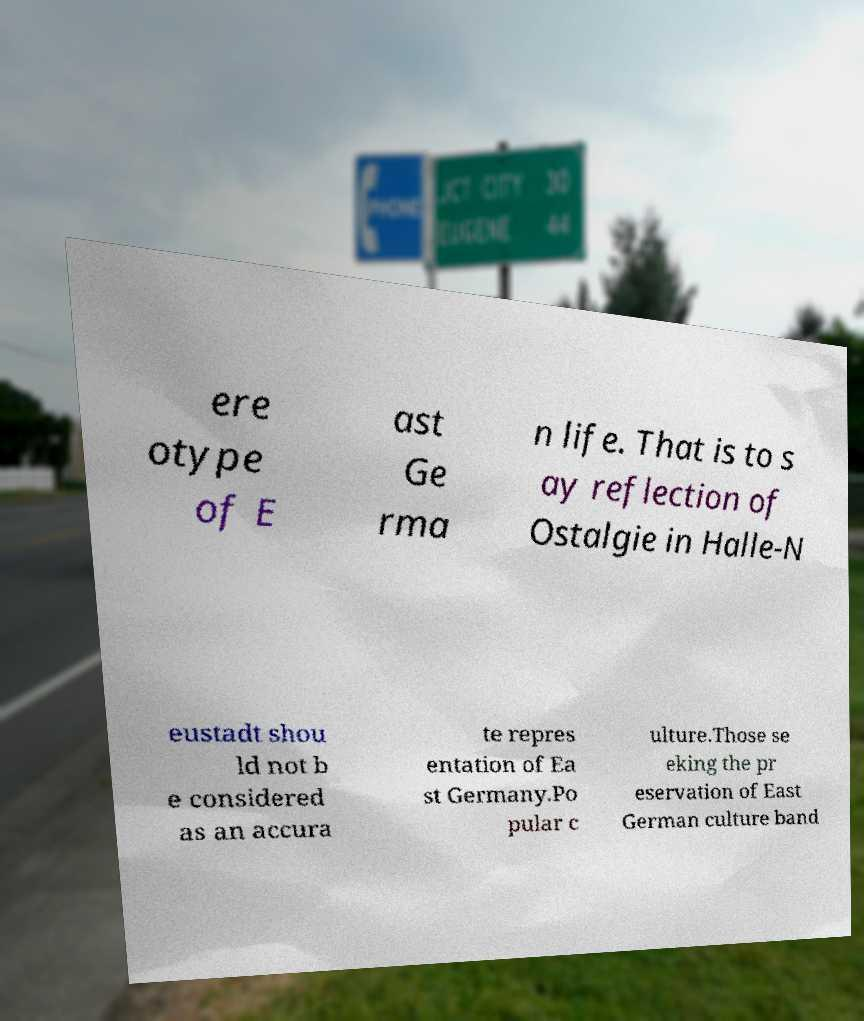Can you accurately transcribe the text from the provided image for me? ere otype of E ast Ge rma n life. That is to s ay reflection of Ostalgie in Halle-N eustadt shou ld not b e considered as an accura te repres entation of Ea st Germany.Po pular c ulture.Those se eking the pr eservation of East German culture band 